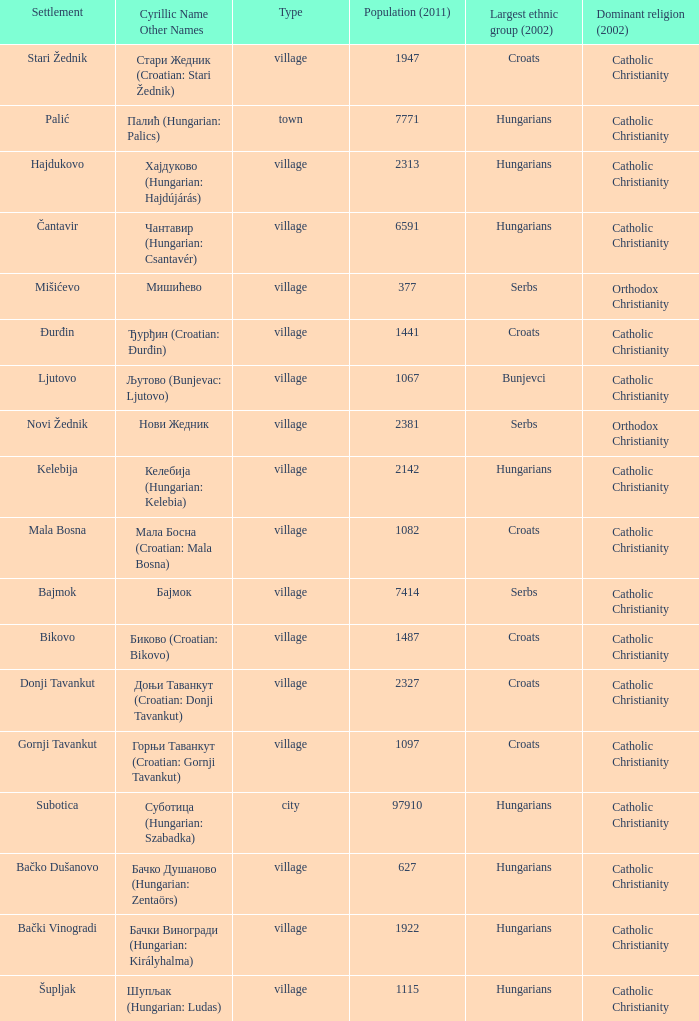What are the cyrillic and other names of the settlement whose population is 6591? Чантавир (Hungarian: Csantavér). 